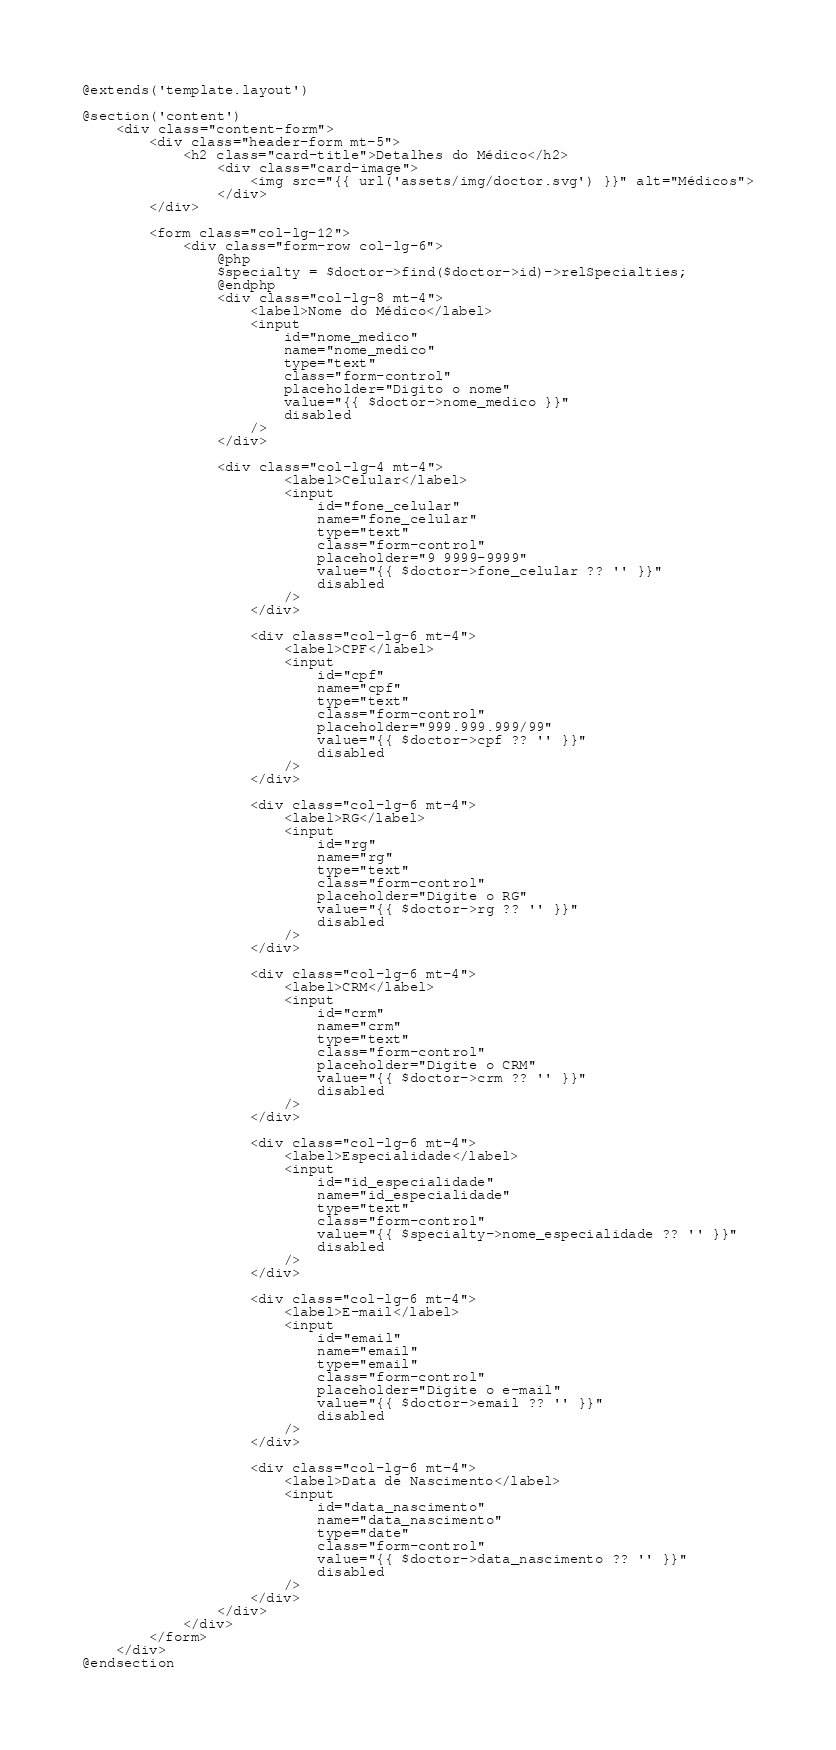<code> <loc_0><loc_0><loc_500><loc_500><_PHP_>@extends('template.layout')

@section('content')
    <div class="content-form">
        <div class="header-form mt-5">
            <h2 class="card-title">Detalhes do Médico</h2>
                <div class="card-image">
                    <img src="{{ url('assets/img/doctor.svg') }}" alt="Médicos">
                </div>
        </div>

        <form class="col-lg-12">
            <div class="form-row col-lg-6">
                @php
                $specialty = $doctor->find($doctor->id)->relSpecialties;
                @endphp
                <div class="col-lg-8 mt-4">
                    <label>Nome do Médico</label>
                    <input 
                        id="nome_medico"
                        name="nome_medico"
                        type="text"
                        class="form-control"
                        placeholder="Digito o nome"
                        value="{{ $doctor->nome_medico }}"
                        disabled
                    />
                </div>    

                <div class="col-lg-4 mt-4">
                        <label>Celular</label>
                        <input 
                            id="fone_celular"
                            name="fone_celular"
                            type="text"
                            class="form-control"
                            placeholder="9 9999-9999"
                            value="{{ $doctor->fone_celular ?? '' }}"
                            disabled
                        />
                    </div>    

                    <div class="col-lg-6 mt-4">
                        <label>CPF</label>
                        <input 
                            id="cpf"
                            name="cpf"
                            type="text"
                            class="form-control"
                            placeholder="999.999.999/99"
                            value="{{ $doctor->cpf ?? '' }}"
                            disabled
                        />
                    </div>    

                    <div class="col-lg-6 mt-4">
                        <label>RG</label>
                        <input 
                            id="rg"
                            name="rg"
                            type="text"
                            class="form-control"
                            placeholder="Digite o RG"
                            value="{{ $doctor->rg ?? '' }}"
                            disabled
                        />
                    </div>      
                    
                    <div class="col-lg-6 mt-4">
                        <label>CRM</label>
                        <input 
                            id="crm"
                            name="crm"
                            type="text"
                            class="form-control"
                            placeholder="Digite o CRM"
                            value="{{ $doctor->crm ?? '' }}"
                            disabled
                        />
                    </div>  
                                        
                    <div class="col-lg-6 mt-4">
                        <label>Especialidade</label>
                        <input 
                            id="id_especialidade"
                            name="id_especialidade"
                            type="text"
                            class="form-control"
                            value="{{ $specialty->nome_especialidade ?? '' }}"
                            disabled
                        />
                    </div> 

                    <div class="col-lg-6 mt-4">
                        <label>E-mail</label>
                        <input 
                            id="email"
                            name="email"
                            type="email"
                            class="form-control"
                            placeholder="Digite o e-mail"
                            value="{{ $doctor->email ?? '' }}"
                            disabled
                        />
                    </div>  
                    
                    <div class="col-lg-6 mt-4">
                        <label>Data de Nascimento</label>
                        <input 
                            id="data_nascimento"
                            name="data_nascimento"
                            type="date"
                            class="form-control"
                            value="{{ $doctor->data_nascimento ?? '' }}"
                            disabled
                        />
                    </div> 
                </div>    
            </div>
        </form>
    </div>
@endsection</code> 